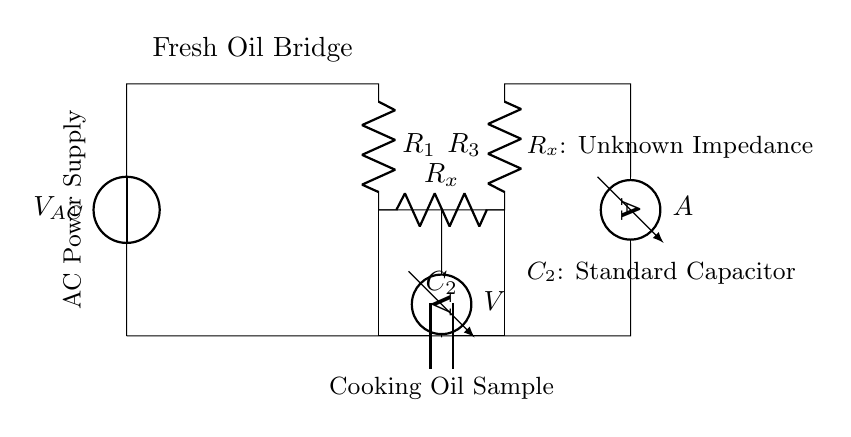What type of source is used in this circuit? The circuit uses an AC power supply. This can be identified from the "V_AC" label in the circuit diagram, which indicates an alternating current voltage source.
Answer: AC power supply What does the component labeled "R_x" represent? The component labeled "R_x" represents an unknown impedance. This is indicated by the label next to the resistor in the circuit diagram, which specifies that it is not a standard value and is used to test the sample.
Answer: Unknown impedance How many resistors are present in the circuit? There are three resistors in total: R_1, R_3, and R_x. This can be counted by examining the circuit diagram where each labeled resistor corresponds to these values.
Answer: Three What is the purpose of the voltmeter in this circuit? The voltmeter is used to measure the voltage across the component marked "R_x". This is derived from its position in the circuit where it connects to R_x, indicating it measures the potential difference across that impedance.
Answer: Measure voltage across R_x What is the significance of the capacitor labeled "C_2"? C_2 is a standard capacitor used to provide a reference for comparison in testing the quality of cooking oils. This reflects its role in the balanced condition of the bridge circuit, where it helps determine the characteristics of the oil sample against a known standard.
Answer: Standard capacitor How is the current measured in this circuit? The current is measured using an ammeter, denoted by "A", which is connected in series with the circuit. The placement of the ammeter indicates it is used to measure the current flowing through the circuit loop.
Answer: Ammeter What type of bridge is represented in this circuit? The represented bridge is a "Fresh Oil Bridge". This is specifically stated in the circuit diagram with the label indicating the purpose of the bridge circuit, which is tailored to test the freshness of cooking oils.
Answer: Fresh Oil Bridge 